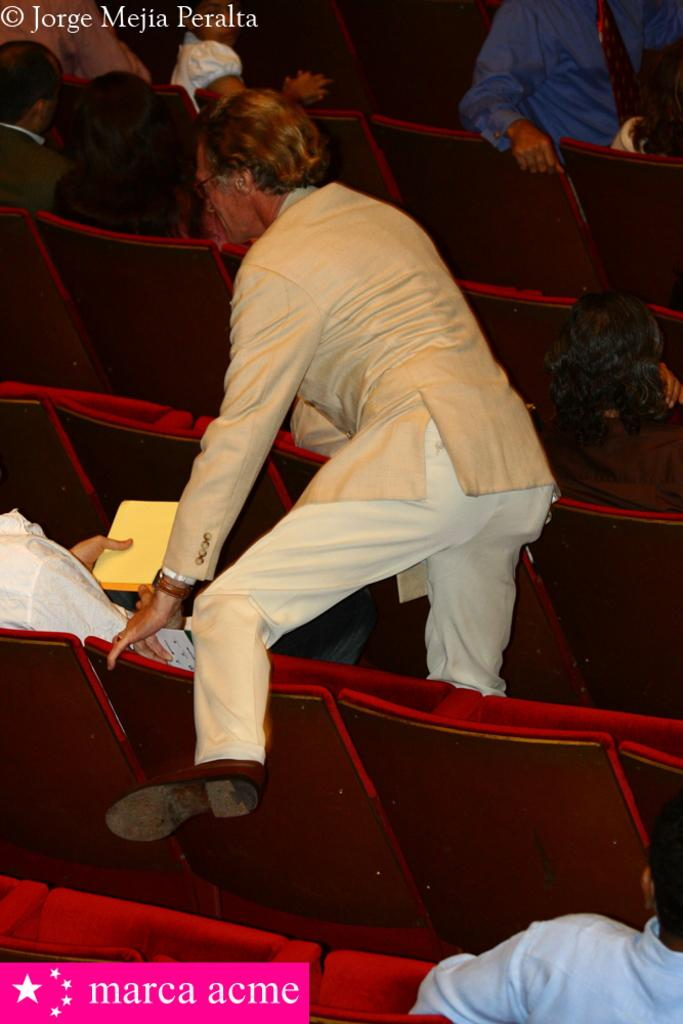What is the man in the image doing? The man in the image is standing on a seat. What are the other people in the image doing? The other people in the image are sitting in seats. What type of zinc material can be seen in the image? There is no zinc material present in the image. What is the temperature like in the image? The temperature cannot be determined from the image alone. 